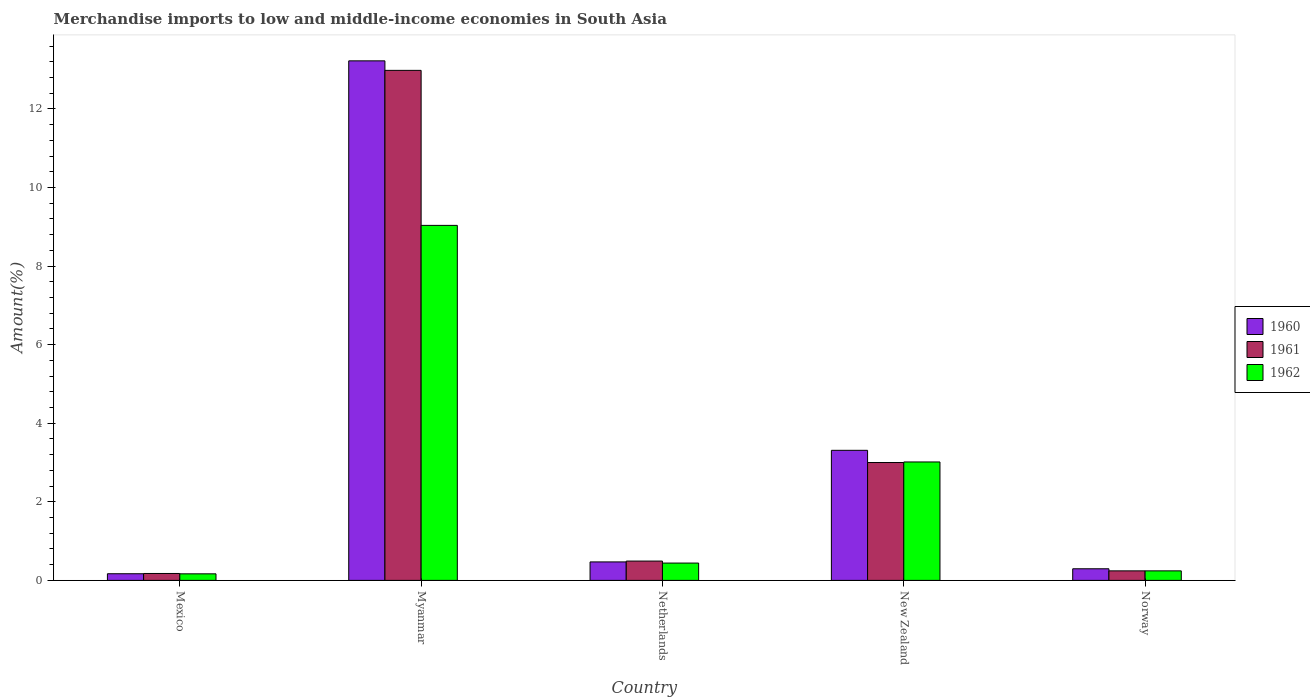How many different coloured bars are there?
Keep it short and to the point. 3. How many groups of bars are there?
Make the answer very short. 5. Are the number of bars per tick equal to the number of legend labels?
Your answer should be compact. Yes. Are the number of bars on each tick of the X-axis equal?
Ensure brevity in your answer.  Yes. How many bars are there on the 1st tick from the left?
Offer a terse response. 3. What is the label of the 1st group of bars from the left?
Provide a short and direct response. Mexico. In how many cases, is the number of bars for a given country not equal to the number of legend labels?
Give a very brief answer. 0. What is the percentage of amount earned from merchandise imports in 1961 in Mexico?
Your answer should be very brief. 0.18. Across all countries, what is the maximum percentage of amount earned from merchandise imports in 1960?
Offer a terse response. 13.22. Across all countries, what is the minimum percentage of amount earned from merchandise imports in 1961?
Give a very brief answer. 0.18. In which country was the percentage of amount earned from merchandise imports in 1961 maximum?
Give a very brief answer. Myanmar. In which country was the percentage of amount earned from merchandise imports in 1962 minimum?
Your response must be concise. Mexico. What is the total percentage of amount earned from merchandise imports in 1960 in the graph?
Provide a succinct answer. 17.47. What is the difference between the percentage of amount earned from merchandise imports in 1961 in Mexico and that in Netherlands?
Your response must be concise. -0.32. What is the difference between the percentage of amount earned from merchandise imports in 1962 in Mexico and the percentage of amount earned from merchandise imports in 1961 in Norway?
Your answer should be very brief. -0.08. What is the average percentage of amount earned from merchandise imports in 1961 per country?
Keep it short and to the point. 3.38. What is the difference between the percentage of amount earned from merchandise imports of/in 1960 and percentage of amount earned from merchandise imports of/in 1962 in Mexico?
Provide a succinct answer. 0. What is the ratio of the percentage of amount earned from merchandise imports in 1962 in Mexico to that in Norway?
Provide a succinct answer. 0.69. Is the percentage of amount earned from merchandise imports in 1962 in Mexico less than that in Netherlands?
Give a very brief answer. Yes. Is the difference between the percentage of amount earned from merchandise imports in 1960 in Netherlands and New Zealand greater than the difference between the percentage of amount earned from merchandise imports in 1962 in Netherlands and New Zealand?
Your response must be concise. No. What is the difference between the highest and the second highest percentage of amount earned from merchandise imports in 1961?
Give a very brief answer. -2.51. What is the difference between the highest and the lowest percentage of amount earned from merchandise imports in 1961?
Your answer should be very brief. 12.81. Is the sum of the percentage of amount earned from merchandise imports in 1961 in New Zealand and Norway greater than the maximum percentage of amount earned from merchandise imports in 1962 across all countries?
Give a very brief answer. No. What does the 2nd bar from the left in New Zealand represents?
Your answer should be very brief. 1961. What does the 2nd bar from the right in Norway represents?
Keep it short and to the point. 1961. How many bars are there?
Your response must be concise. 15. Are all the bars in the graph horizontal?
Your answer should be compact. No. How many countries are there in the graph?
Offer a terse response. 5. Are the values on the major ticks of Y-axis written in scientific E-notation?
Keep it short and to the point. No. Does the graph contain grids?
Your answer should be compact. No. Where does the legend appear in the graph?
Ensure brevity in your answer.  Center right. How many legend labels are there?
Ensure brevity in your answer.  3. What is the title of the graph?
Your answer should be compact. Merchandise imports to low and middle-income economies in South Asia. What is the label or title of the Y-axis?
Keep it short and to the point. Amount(%). What is the Amount(%) of 1960 in Mexico?
Your answer should be compact. 0.17. What is the Amount(%) in 1961 in Mexico?
Provide a succinct answer. 0.18. What is the Amount(%) of 1962 in Mexico?
Provide a succinct answer. 0.17. What is the Amount(%) in 1960 in Myanmar?
Provide a short and direct response. 13.22. What is the Amount(%) of 1961 in Myanmar?
Give a very brief answer. 12.98. What is the Amount(%) of 1962 in Myanmar?
Make the answer very short. 9.04. What is the Amount(%) in 1960 in Netherlands?
Your answer should be very brief. 0.47. What is the Amount(%) of 1961 in Netherlands?
Keep it short and to the point. 0.49. What is the Amount(%) of 1962 in Netherlands?
Keep it short and to the point. 0.44. What is the Amount(%) of 1960 in New Zealand?
Your response must be concise. 3.31. What is the Amount(%) in 1961 in New Zealand?
Your answer should be compact. 3. What is the Amount(%) of 1962 in New Zealand?
Offer a very short reply. 3.01. What is the Amount(%) in 1960 in Norway?
Give a very brief answer. 0.3. What is the Amount(%) of 1961 in Norway?
Keep it short and to the point. 0.24. What is the Amount(%) of 1962 in Norway?
Keep it short and to the point. 0.24. Across all countries, what is the maximum Amount(%) in 1960?
Ensure brevity in your answer.  13.22. Across all countries, what is the maximum Amount(%) in 1961?
Make the answer very short. 12.98. Across all countries, what is the maximum Amount(%) of 1962?
Your answer should be compact. 9.04. Across all countries, what is the minimum Amount(%) of 1960?
Make the answer very short. 0.17. Across all countries, what is the minimum Amount(%) in 1961?
Your answer should be very brief. 0.18. Across all countries, what is the minimum Amount(%) in 1962?
Provide a short and direct response. 0.17. What is the total Amount(%) in 1960 in the graph?
Your response must be concise. 17.47. What is the total Amount(%) of 1961 in the graph?
Offer a very short reply. 16.89. What is the total Amount(%) of 1962 in the graph?
Make the answer very short. 12.9. What is the difference between the Amount(%) of 1960 in Mexico and that in Myanmar?
Give a very brief answer. -13.05. What is the difference between the Amount(%) of 1961 in Mexico and that in Myanmar?
Your response must be concise. -12.81. What is the difference between the Amount(%) in 1962 in Mexico and that in Myanmar?
Make the answer very short. -8.87. What is the difference between the Amount(%) in 1960 in Mexico and that in Netherlands?
Your answer should be very brief. -0.3. What is the difference between the Amount(%) of 1961 in Mexico and that in Netherlands?
Ensure brevity in your answer.  -0.32. What is the difference between the Amount(%) of 1962 in Mexico and that in Netherlands?
Provide a short and direct response. -0.27. What is the difference between the Amount(%) of 1960 in Mexico and that in New Zealand?
Your answer should be compact. -3.14. What is the difference between the Amount(%) of 1961 in Mexico and that in New Zealand?
Your answer should be very brief. -2.82. What is the difference between the Amount(%) of 1962 in Mexico and that in New Zealand?
Offer a very short reply. -2.85. What is the difference between the Amount(%) in 1960 in Mexico and that in Norway?
Give a very brief answer. -0.13. What is the difference between the Amount(%) of 1961 in Mexico and that in Norway?
Your response must be concise. -0.07. What is the difference between the Amount(%) of 1962 in Mexico and that in Norway?
Your answer should be very brief. -0.08. What is the difference between the Amount(%) in 1960 in Myanmar and that in Netherlands?
Your answer should be very brief. 12.75. What is the difference between the Amount(%) in 1961 in Myanmar and that in Netherlands?
Provide a short and direct response. 12.49. What is the difference between the Amount(%) in 1962 in Myanmar and that in Netherlands?
Keep it short and to the point. 8.6. What is the difference between the Amount(%) in 1960 in Myanmar and that in New Zealand?
Your answer should be very brief. 9.91. What is the difference between the Amount(%) in 1961 in Myanmar and that in New Zealand?
Keep it short and to the point. 9.98. What is the difference between the Amount(%) in 1962 in Myanmar and that in New Zealand?
Keep it short and to the point. 6.02. What is the difference between the Amount(%) in 1960 in Myanmar and that in Norway?
Your answer should be very brief. 12.93. What is the difference between the Amount(%) of 1961 in Myanmar and that in Norway?
Give a very brief answer. 12.74. What is the difference between the Amount(%) in 1962 in Myanmar and that in Norway?
Provide a short and direct response. 8.79. What is the difference between the Amount(%) of 1960 in Netherlands and that in New Zealand?
Your answer should be compact. -2.84. What is the difference between the Amount(%) in 1961 in Netherlands and that in New Zealand?
Give a very brief answer. -2.51. What is the difference between the Amount(%) in 1962 in Netherlands and that in New Zealand?
Provide a succinct answer. -2.57. What is the difference between the Amount(%) of 1960 in Netherlands and that in Norway?
Offer a very short reply. 0.17. What is the difference between the Amount(%) in 1961 in Netherlands and that in Norway?
Your answer should be very brief. 0.25. What is the difference between the Amount(%) in 1962 in Netherlands and that in Norway?
Ensure brevity in your answer.  0.2. What is the difference between the Amount(%) of 1960 in New Zealand and that in Norway?
Make the answer very short. 3.02. What is the difference between the Amount(%) in 1961 in New Zealand and that in Norway?
Make the answer very short. 2.76. What is the difference between the Amount(%) in 1962 in New Zealand and that in Norway?
Your answer should be compact. 2.77. What is the difference between the Amount(%) in 1960 in Mexico and the Amount(%) in 1961 in Myanmar?
Give a very brief answer. -12.81. What is the difference between the Amount(%) of 1960 in Mexico and the Amount(%) of 1962 in Myanmar?
Keep it short and to the point. -8.87. What is the difference between the Amount(%) of 1961 in Mexico and the Amount(%) of 1962 in Myanmar?
Give a very brief answer. -8.86. What is the difference between the Amount(%) of 1960 in Mexico and the Amount(%) of 1961 in Netherlands?
Offer a terse response. -0.32. What is the difference between the Amount(%) of 1960 in Mexico and the Amount(%) of 1962 in Netherlands?
Give a very brief answer. -0.27. What is the difference between the Amount(%) of 1961 in Mexico and the Amount(%) of 1962 in Netherlands?
Offer a very short reply. -0.26. What is the difference between the Amount(%) in 1960 in Mexico and the Amount(%) in 1961 in New Zealand?
Give a very brief answer. -2.83. What is the difference between the Amount(%) of 1960 in Mexico and the Amount(%) of 1962 in New Zealand?
Ensure brevity in your answer.  -2.85. What is the difference between the Amount(%) of 1961 in Mexico and the Amount(%) of 1962 in New Zealand?
Make the answer very short. -2.84. What is the difference between the Amount(%) of 1960 in Mexico and the Amount(%) of 1961 in Norway?
Offer a terse response. -0.07. What is the difference between the Amount(%) of 1960 in Mexico and the Amount(%) of 1962 in Norway?
Provide a short and direct response. -0.07. What is the difference between the Amount(%) in 1961 in Mexico and the Amount(%) in 1962 in Norway?
Your answer should be compact. -0.07. What is the difference between the Amount(%) in 1960 in Myanmar and the Amount(%) in 1961 in Netherlands?
Offer a terse response. 12.73. What is the difference between the Amount(%) of 1960 in Myanmar and the Amount(%) of 1962 in Netherlands?
Keep it short and to the point. 12.78. What is the difference between the Amount(%) in 1961 in Myanmar and the Amount(%) in 1962 in Netherlands?
Your response must be concise. 12.54. What is the difference between the Amount(%) of 1960 in Myanmar and the Amount(%) of 1961 in New Zealand?
Give a very brief answer. 10.22. What is the difference between the Amount(%) of 1960 in Myanmar and the Amount(%) of 1962 in New Zealand?
Provide a short and direct response. 10.21. What is the difference between the Amount(%) of 1961 in Myanmar and the Amount(%) of 1962 in New Zealand?
Make the answer very short. 9.97. What is the difference between the Amount(%) in 1960 in Myanmar and the Amount(%) in 1961 in Norway?
Your answer should be compact. 12.98. What is the difference between the Amount(%) of 1960 in Myanmar and the Amount(%) of 1962 in Norway?
Offer a terse response. 12.98. What is the difference between the Amount(%) of 1961 in Myanmar and the Amount(%) of 1962 in Norway?
Your answer should be compact. 12.74. What is the difference between the Amount(%) in 1960 in Netherlands and the Amount(%) in 1961 in New Zealand?
Give a very brief answer. -2.53. What is the difference between the Amount(%) in 1960 in Netherlands and the Amount(%) in 1962 in New Zealand?
Your answer should be compact. -2.54. What is the difference between the Amount(%) in 1961 in Netherlands and the Amount(%) in 1962 in New Zealand?
Make the answer very short. -2.52. What is the difference between the Amount(%) in 1960 in Netherlands and the Amount(%) in 1961 in Norway?
Offer a very short reply. 0.23. What is the difference between the Amount(%) in 1960 in Netherlands and the Amount(%) in 1962 in Norway?
Your answer should be compact. 0.23. What is the difference between the Amount(%) in 1961 in Netherlands and the Amount(%) in 1962 in Norway?
Your response must be concise. 0.25. What is the difference between the Amount(%) of 1960 in New Zealand and the Amount(%) of 1961 in Norway?
Provide a short and direct response. 3.07. What is the difference between the Amount(%) of 1960 in New Zealand and the Amount(%) of 1962 in Norway?
Provide a short and direct response. 3.07. What is the difference between the Amount(%) of 1961 in New Zealand and the Amount(%) of 1962 in Norway?
Offer a very short reply. 2.76. What is the average Amount(%) of 1960 per country?
Offer a very short reply. 3.49. What is the average Amount(%) in 1961 per country?
Give a very brief answer. 3.38. What is the average Amount(%) of 1962 per country?
Keep it short and to the point. 2.58. What is the difference between the Amount(%) in 1960 and Amount(%) in 1961 in Mexico?
Offer a very short reply. -0.01. What is the difference between the Amount(%) of 1960 and Amount(%) of 1962 in Mexico?
Offer a very short reply. 0. What is the difference between the Amount(%) of 1961 and Amount(%) of 1962 in Mexico?
Your response must be concise. 0.01. What is the difference between the Amount(%) in 1960 and Amount(%) in 1961 in Myanmar?
Offer a very short reply. 0.24. What is the difference between the Amount(%) of 1960 and Amount(%) of 1962 in Myanmar?
Offer a terse response. 4.19. What is the difference between the Amount(%) of 1961 and Amount(%) of 1962 in Myanmar?
Give a very brief answer. 3.95. What is the difference between the Amount(%) of 1960 and Amount(%) of 1961 in Netherlands?
Offer a very short reply. -0.02. What is the difference between the Amount(%) of 1960 and Amount(%) of 1962 in Netherlands?
Offer a terse response. 0.03. What is the difference between the Amount(%) of 1961 and Amount(%) of 1962 in Netherlands?
Make the answer very short. 0.05. What is the difference between the Amount(%) in 1960 and Amount(%) in 1961 in New Zealand?
Offer a terse response. 0.31. What is the difference between the Amount(%) of 1960 and Amount(%) of 1962 in New Zealand?
Your answer should be compact. 0.3. What is the difference between the Amount(%) of 1961 and Amount(%) of 1962 in New Zealand?
Make the answer very short. -0.01. What is the difference between the Amount(%) of 1960 and Amount(%) of 1961 in Norway?
Ensure brevity in your answer.  0.05. What is the difference between the Amount(%) in 1960 and Amount(%) in 1962 in Norway?
Offer a terse response. 0.05. What is the difference between the Amount(%) in 1961 and Amount(%) in 1962 in Norway?
Your answer should be compact. 0. What is the ratio of the Amount(%) in 1960 in Mexico to that in Myanmar?
Offer a very short reply. 0.01. What is the ratio of the Amount(%) of 1961 in Mexico to that in Myanmar?
Provide a short and direct response. 0.01. What is the ratio of the Amount(%) of 1962 in Mexico to that in Myanmar?
Offer a very short reply. 0.02. What is the ratio of the Amount(%) of 1960 in Mexico to that in Netherlands?
Your answer should be compact. 0.36. What is the ratio of the Amount(%) of 1961 in Mexico to that in Netherlands?
Offer a terse response. 0.36. What is the ratio of the Amount(%) of 1962 in Mexico to that in Netherlands?
Provide a short and direct response. 0.38. What is the ratio of the Amount(%) in 1960 in Mexico to that in New Zealand?
Make the answer very short. 0.05. What is the ratio of the Amount(%) in 1961 in Mexico to that in New Zealand?
Offer a terse response. 0.06. What is the ratio of the Amount(%) in 1962 in Mexico to that in New Zealand?
Make the answer very short. 0.06. What is the ratio of the Amount(%) of 1960 in Mexico to that in Norway?
Your answer should be very brief. 0.57. What is the ratio of the Amount(%) in 1961 in Mexico to that in Norway?
Ensure brevity in your answer.  0.73. What is the ratio of the Amount(%) in 1962 in Mexico to that in Norway?
Give a very brief answer. 0.69. What is the ratio of the Amount(%) in 1960 in Myanmar to that in Netherlands?
Provide a succinct answer. 28.12. What is the ratio of the Amount(%) in 1961 in Myanmar to that in Netherlands?
Keep it short and to the point. 26.4. What is the ratio of the Amount(%) in 1962 in Myanmar to that in Netherlands?
Offer a terse response. 20.5. What is the ratio of the Amount(%) in 1960 in Myanmar to that in New Zealand?
Offer a terse response. 3.99. What is the ratio of the Amount(%) of 1961 in Myanmar to that in New Zealand?
Provide a succinct answer. 4.33. What is the ratio of the Amount(%) in 1962 in Myanmar to that in New Zealand?
Make the answer very short. 3. What is the ratio of the Amount(%) in 1960 in Myanmar to that in Norway?
Make the answer very short. 44.71. What is the ratio of the Amount(%) in 1961 in Myanmar to that in Norway?
Offer a terse response. 53.54. What is the ratio of the Amount(%) of 1962 in Myanmar to that in Norway?
Keep it short and to the point. 37.28. What is the ratio of the Amount(%) in 1960 in Netherlands to that in New Zealand?
Give a very brief answer. 0.14. What is the ratio of the Amount(%) in 1961 in Netherlands to that in New Zealand?
Your response must be concise. 0.16. What is the ratio of the Amount(%) of 1962 in Netherlands to that in New Zealand?
Provide a succinct answer. 0.15. What is the ratio of the Amount(%) of 1960 in Netherlands to that in Norway?
Make the answer very short. 1.59. What is the ratio of the Amount(%) of 1961 in Netherlands to that in Norway?
Give a very brief answer. 2.03. What is the ratio of the Amount(%) of 1962 in Netherlands to that in Norway?
Give a very brief answer. 1.82. What is the ratio of the Amount(%) in 1960 in New Zealand to that in Norway?
Offer a very short reply. 11.19. What is the ratio of the Amount(%) of 1961 in New Zealand to that in Norway?
Make the answer very short. 12.37. What is the ratio of the Amount(%) of 1962 in New Zealand to that in Norway?
Your answer should be compact. 12.44. What is the difference between the highest and the second highest Amount(%) in 1960?
Offer a terse response. 9.91. What is the difference between the highest and the second highest Amount(%) in 1961?
Your response must be concise. 9.98. What is the difference between the highest and the second highest Amount(%) in 1962?
Your response must be concise. 6.02. What is the difference between the highest and the lowest Amount(%) of 1960?
Offer a very short reply. 13.05. What is the difference between the highest and the lowest Amount(%) in 1961?
Keep it short and to the point. 12.81. What is the difference between the highest and the lowest Amount(%) in 1962?
Keep it short and to the point. 8.87. 